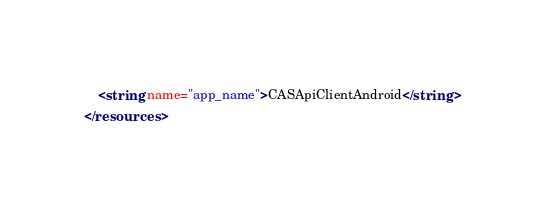<code> <loc_0><loc_0><loc_500><loc_500><_XML_>    <string name="app_name">CASApiClientAndroid</string>
</resources>
</code> 